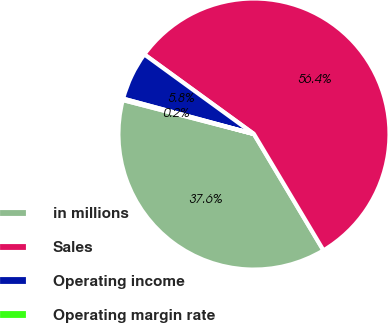Convert chart. <chart><loc_0><loc_0><loc_500><loc_500><pie_chart><fcel>in millions<fcel>Sales<fcel>Operating income<fcel>Operating margin rate<nl><fcel>37.61%<fcel>56.43%<fcel>5.79%<fcel>0.17%<nl></chart> 